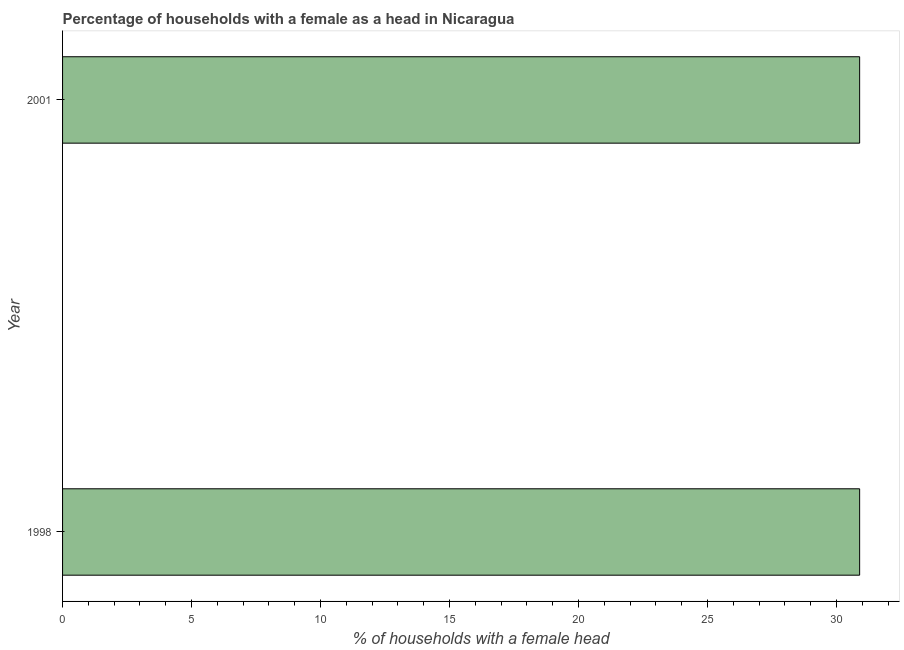What is the title of the graph?
Offer a very short reply. Percentage of households with a female as a head in Nicaragua. What is the label or title of the X-axis?
Offer a terse response. % of households with a female head. What is the label or title of the Y-axis?
Give a very brief answer. Year. What is the number of female supervised households in 1998?
Your answer should be very brief. 30.9. Across all years, what is the maximum number of female supervised households?
Provide a succinct answer. 30.9. Across all years, what is the minimum number of female supervised households?
Your answer should be very brief. 30.9. In which year was the number of female supervised households maximum?
Offer a very short reply. 1998. In which year was the number of female supervised households minimum?
Provide a short and direct response. 1998. What is the sum of the number of female supervised households?
Provide a short and direct response. 61.8. What is the difference between the number of female supervised households in 1998 and 2001?
Your answer should be compact. 0. What is the average number of female supervised households per year?
Your response must be concise. 30.9. What is the median number of female supervised households?
Offer a very short reply. 30.9. Do a majority of the years between 1998 and 2001 (inclusive) have number of female supervised households greater than 7 %?
Ensure brevity in your answer.  Yes. Are all the bars in the graph horizontal?
Give a very brief answer. Yes. Are the values on the major ticks of X-axis written in scientific E-notation?
Provide a short and direct response. No. What is the % of households with a female head of 1998?
Your answer should be very brief. 30.9. What is the % of households with a female head in 2001?
Keep it short and to the point. 30.9. What is the ratio of the % of households with a female head in 1998 to that in 2001?
Your answer should be very brief. 1. 